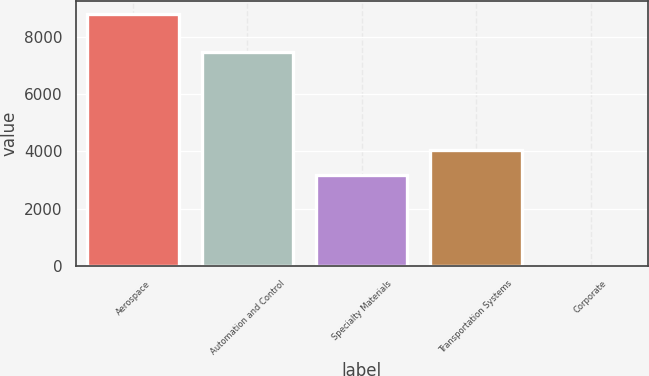Convert chart. <chart><loc_0><loc_0><loc_500><loc_500><bar_chart><fcel>Aerospace<fcel>Automation and Control<fcel>Specialty Materials<fcel>Transportation Systems<fcel>Corporate<nl><fcel>8813<fcel>7464<fcel>3169<fcel>4049.6<fcel>7<nl></chart> 